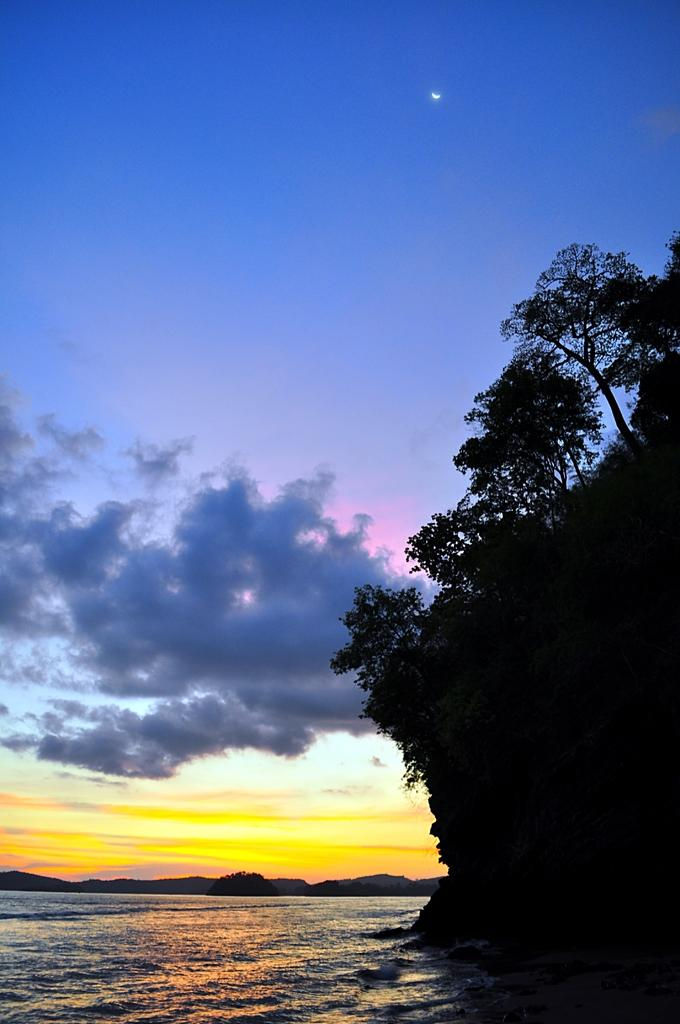What type of vegetation can be seen near the water in the image? There are trees beside the water in the image. What can be seen in the sky in the image? Clouds and the moon are visible in the sky. What type of landscape is visible in the background of the image? There are mountains in the background of the image. What type of paint is being used to create the distribution of advice in the image? There is no paint, distribution, or advice present in the image; it features trees, water, clouds, the moon, and mountains. 